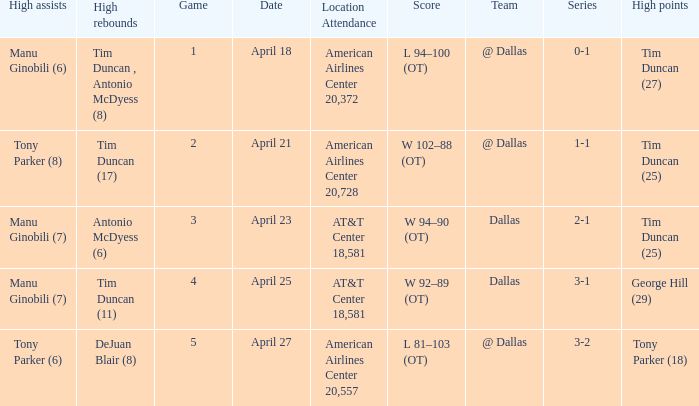When 5 is the game who has the highest amount of points? Tony Parker (18). 